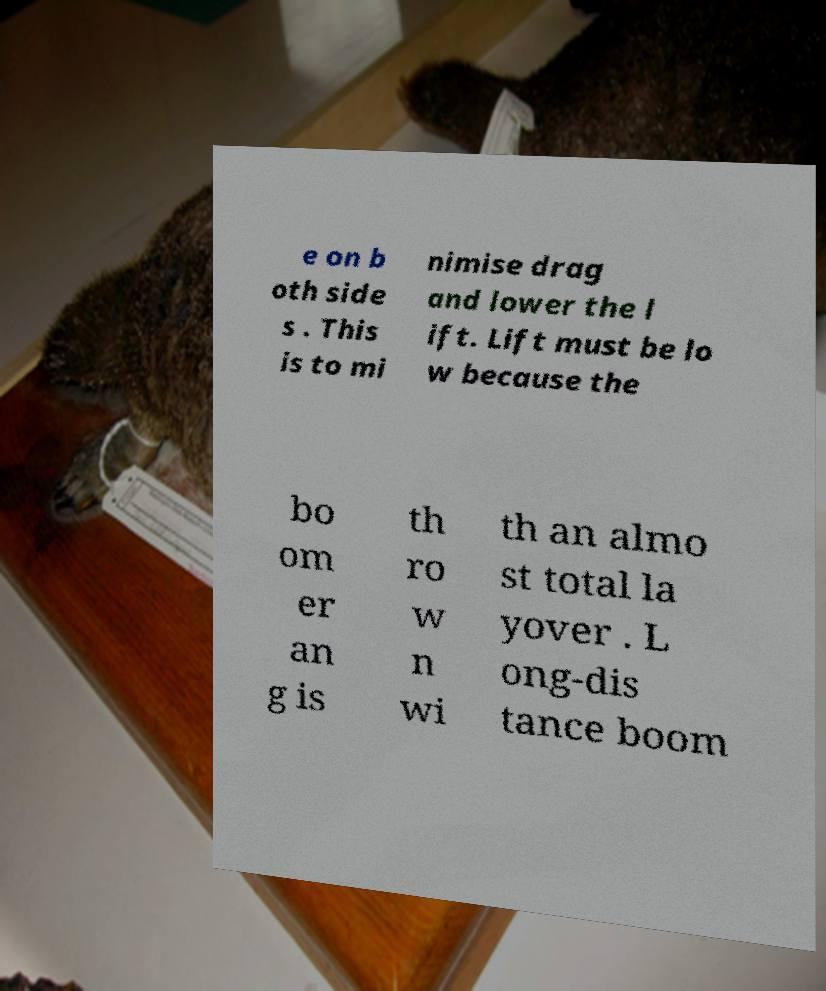There's text embedded in this image that I need extracted. Can you transcribe it verbatim? e on b oth side s . This is to mi nimise drag and lower the l ift. Lift must be lo w because the bo om er an g is th ro w n wi th an almo st total la yover . L ong-dis tance boom 